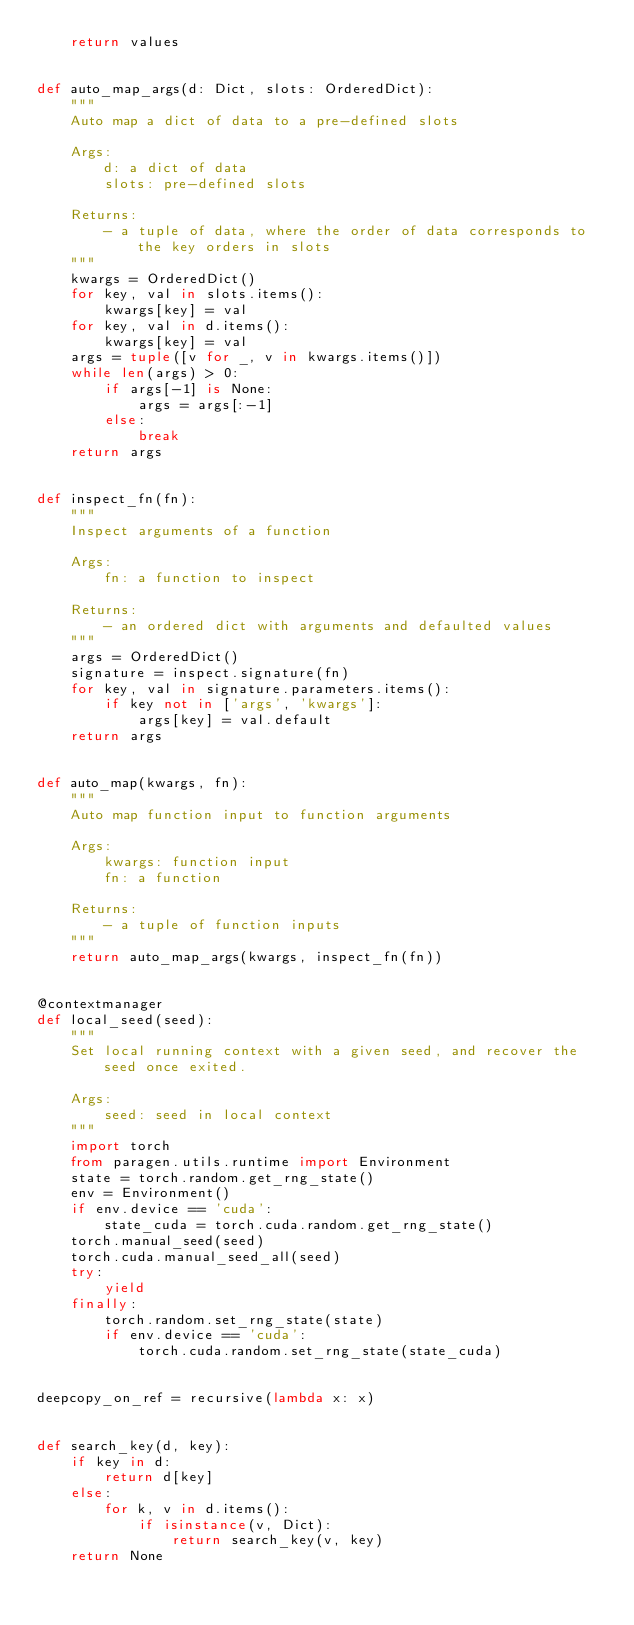Convert code to text. <code><loc_0><loc_0><loc_500><loc_500><_Python_>    return values


def auto_map_args(d: Dict, slots: OrderedDict):
    """
    Auto map a dict of data to a pre-defined slots

    Args:
        d: a dict of data
        slots: pre-defined slots

    Returns:
        - a tuple of data, where the order of data corresponds to the key orders in slots
    """
    kwargs = OrderedDict()
    for key, val in slots.items():
        kwargs[key] = val
    for key, val in d.items():
        kwargs[key] = val
    args = tuple([v for _, v in kwargs.items()])
    while len(args) > 0:
        if args[-1] is None:
            args = args[:-1]
        else:
            break
    return args


def inspect_fn(fn):
    """
    Inspect arguments of a function

    Args:
        fn: a function to inspect

    Returns:
        - an ordered dict with arguments and defaulted values
    """
    args = OrderedDict()
    signature = inspect.signature(fn)
    for key, val in signature.parameters.items():
        if key not in ['args', 'kwargs']:
            args[key] = val.default
    return args


def auto_map(kwargs, fn):
    """
    Auto map function input to function arguments

    Args:
        kwargs: function input
        fn: a function

    Returns:
        - a tuple of function inputs
    """
    return auto_map_args(kwargs, inspect_fn(fn))


@contextmanager
def local_seed(seed):
    """
    Set local running context with a given seed, and recover the seed once exited.

    Args:
        seed: seed in local context
    """
    import torch
    from paragen.utils.runtime import Environment
    state = torch.random.get_rng_state()
    env = Environment()
    if env.device == 'cuda':
        state_cuda = torch.cuda.random.get_rng_state()
    torch.manual_seed(seed)
    torch.cuda.manual_seed_all(seed)
    try:
        yield
    finally:
        torch.random.set_rng_state(state)
        if env.device == 'cuda':
            torch.cuda.random.set_rng_state(state_cuda)


deepcopy_on_ref = recursive(lambda x: x)


def search_key(d, key):
    if key in d:
        return d[key]
    else:
        for k, v in d.items():
            if isinstance(v, Dict):
                return search_key(v, key)
    return None
</code> 